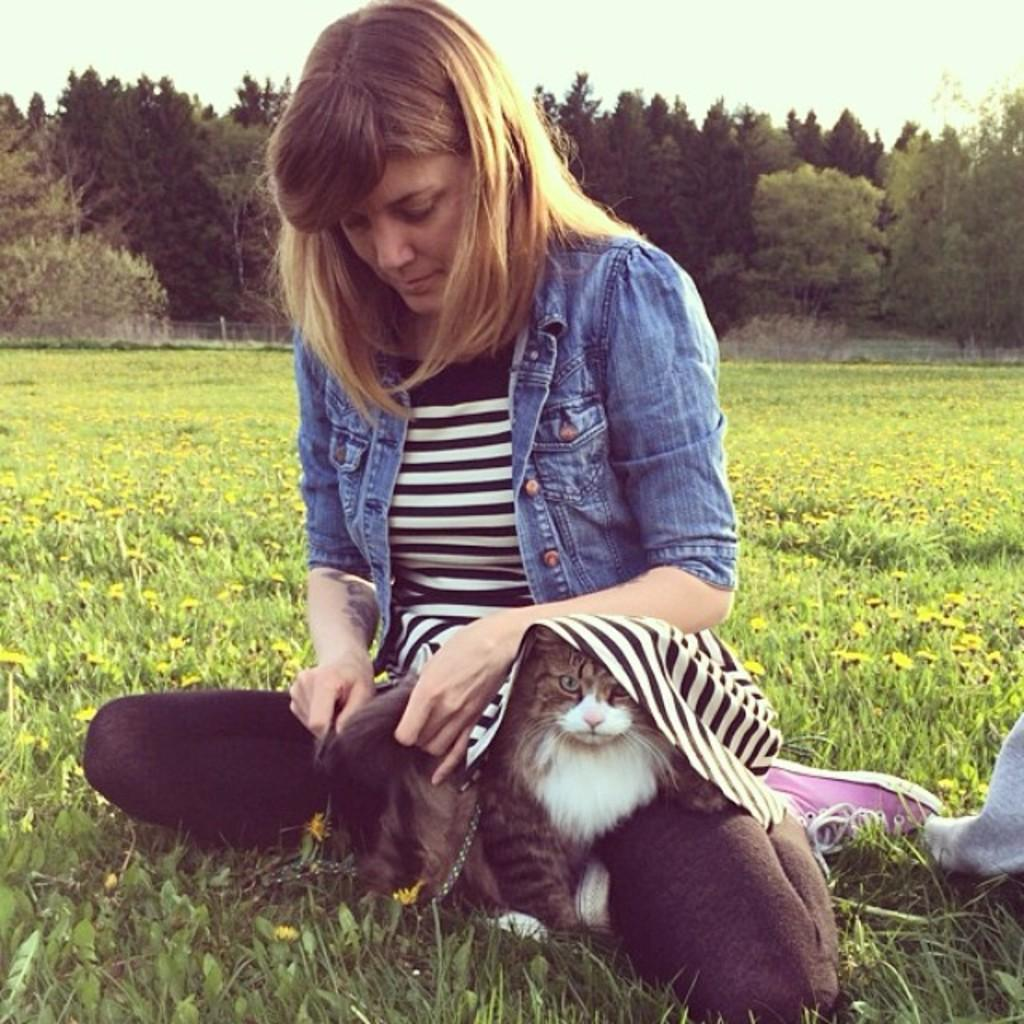Who is present in the image? There is a woman in the image. Where is the woman located? The woman is sitting in a garden. Is there any animal with the woman? Yes, there is a cat with the woman. What can be seen in the background of the image? There is a tree and the sky visible in the background of the image. What subject is the woman teaching in the image? There is no indication in the image that the woman is teaching any subject. Can you see any fairies flying around the woman in the image? There are no fairies present in the image. 